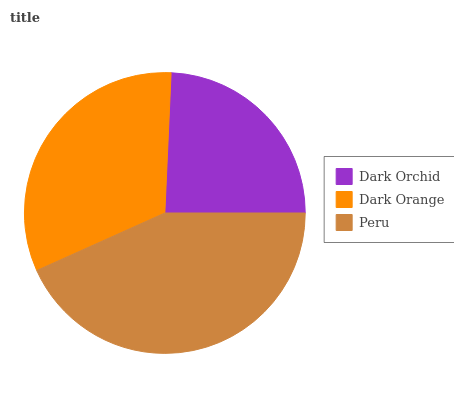Is Dark Orchid the minimum?
Answer yes or no. Yes. Is Peru the maximum?
Answer yes or no. Yes. Is Dark Orange the minimum?
Answer yes or no. No. Is Dark Orange the maximum?
Answer yes or no. No. Is Dark Orange greater than Dark Orchid?
Answer yes or no. Yes. Is Dark Orchid less than Dark Orange?
Answer yes or no. Yes. Is Dark Orchid greater than Dark Orange?
Answer yes or no. No. Is Dark Orange less than Dark Orchid?
Answer yes or no. No. Is Dark Orange the high median?
Answer yes or no. Yes. Is Dark Orange the low median?
Answer yes or no. Yes. Is Dark Orchid the high median?
Answer yes or no. No. Is Dark Orchid the low median?
Answer yes or no. No. 